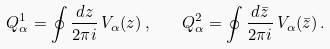<formula> <loc_0><loc_0><loc_500><loc_500>Q _ { \alpha } ^ { 1 } = \oint \frac { d z } { 2 \pi i } \, V _ { \alpha } ( z ) \, , \quad Q _ { \alpha } ^ { 2 } = \oint \frac { d \bar { z } } { 2 \pi i } \, V _ { \alpha } ( \bar { z } ) \, .</formula> 